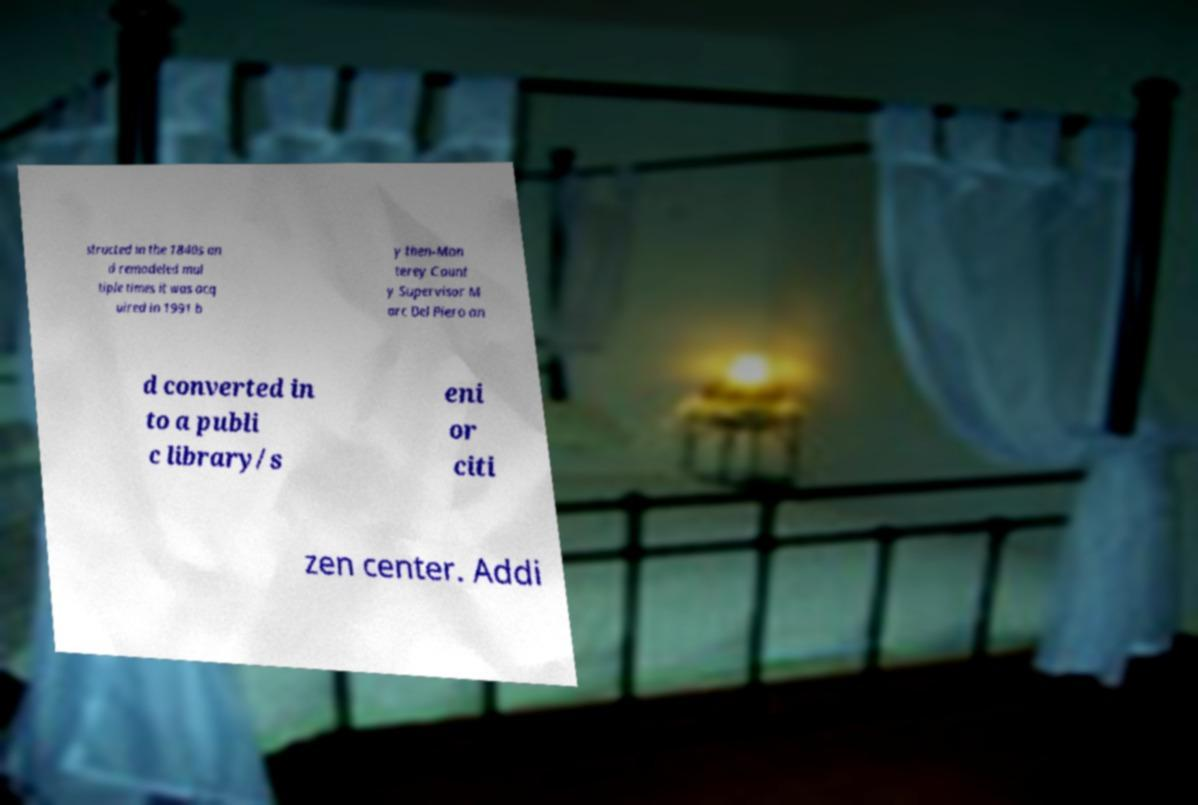Can you accurately transcribe the text from the provided image for me? structed in the 1840s an d remodeled mul tiple times it was acq uired in 1991 b y then-Mon terey Count y Supervisor M arc Del Piero an d converted in to a publi c library/s eni or citi zen center. Addi 